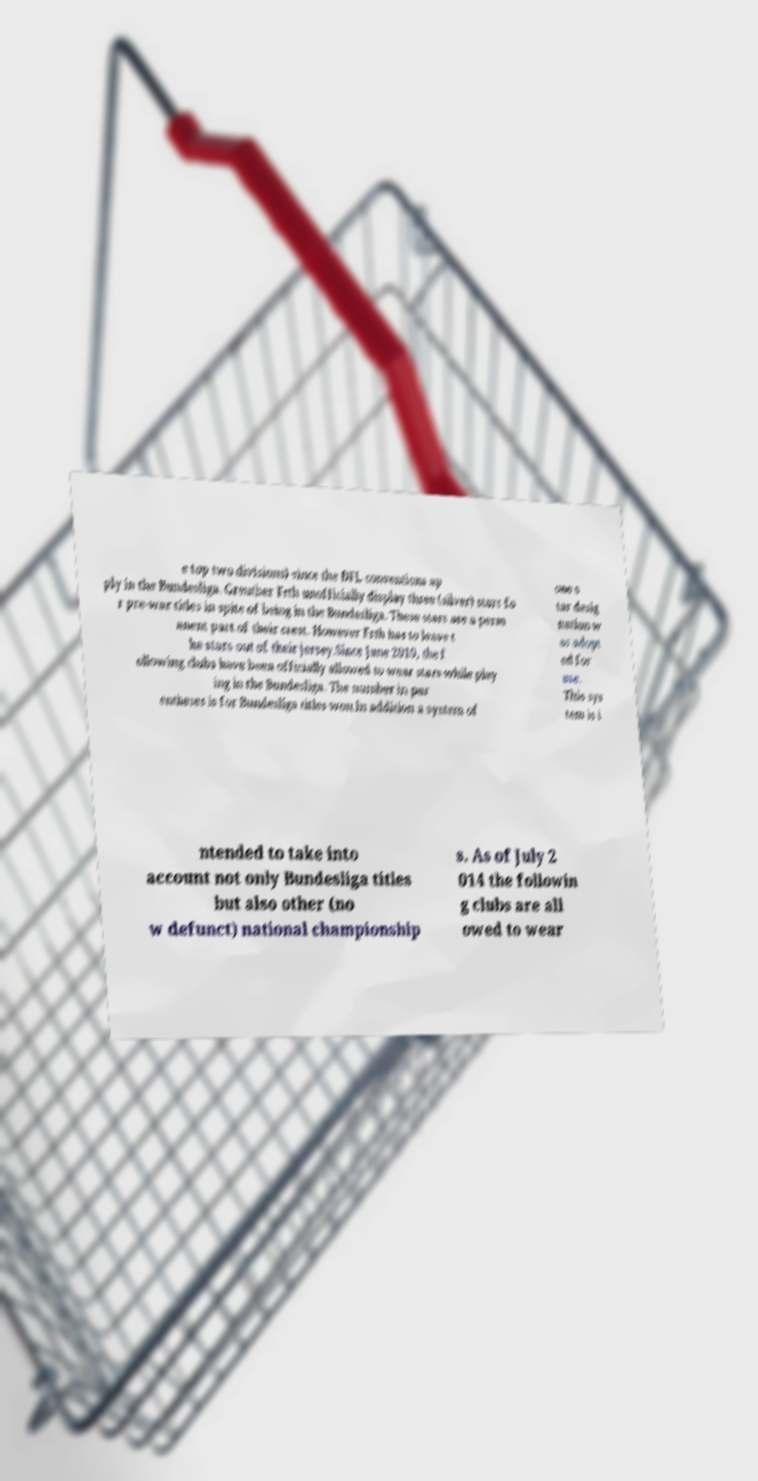For documentation purposes, I need the text within this image transcribed. Could you provide that? e top two divisions) since the DFL conventions ap ply in the Bundesliga. Greuther Frth unofficially display three (silver) stars fo r pre-war titles in spite of being in the Bundesliga. These stars are a perm anent part of their crest. However Frth has to leave t he stars out of their jersey.Since June 2010, the f ollowing clubs have been officially allowed to wear stars while play ing in the Bundesliga. The number in par entheses is for Bundesliga titles won.In addition a system of one s tar desig nation w as adopt ed for use. This sys tem is i ntended to take into account not only Bundesliga titles but also other (no w defunct) national championship s. As of July 2 014 the followin g clubs are all owed to wear 